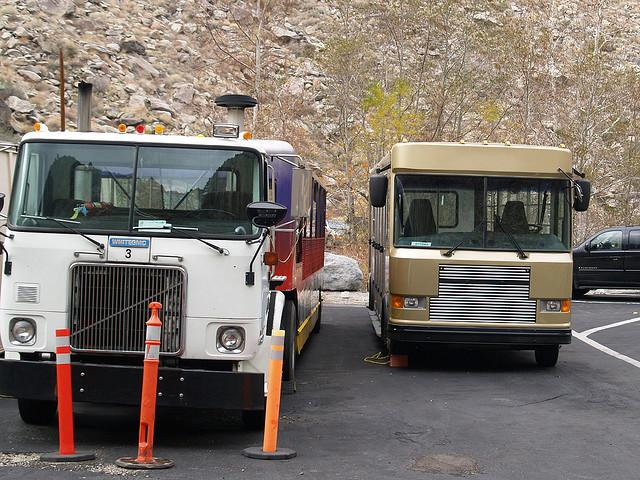What are these vehicles called?

Choices:
A) planes
B) cars
C) tanks
D) buses buses 